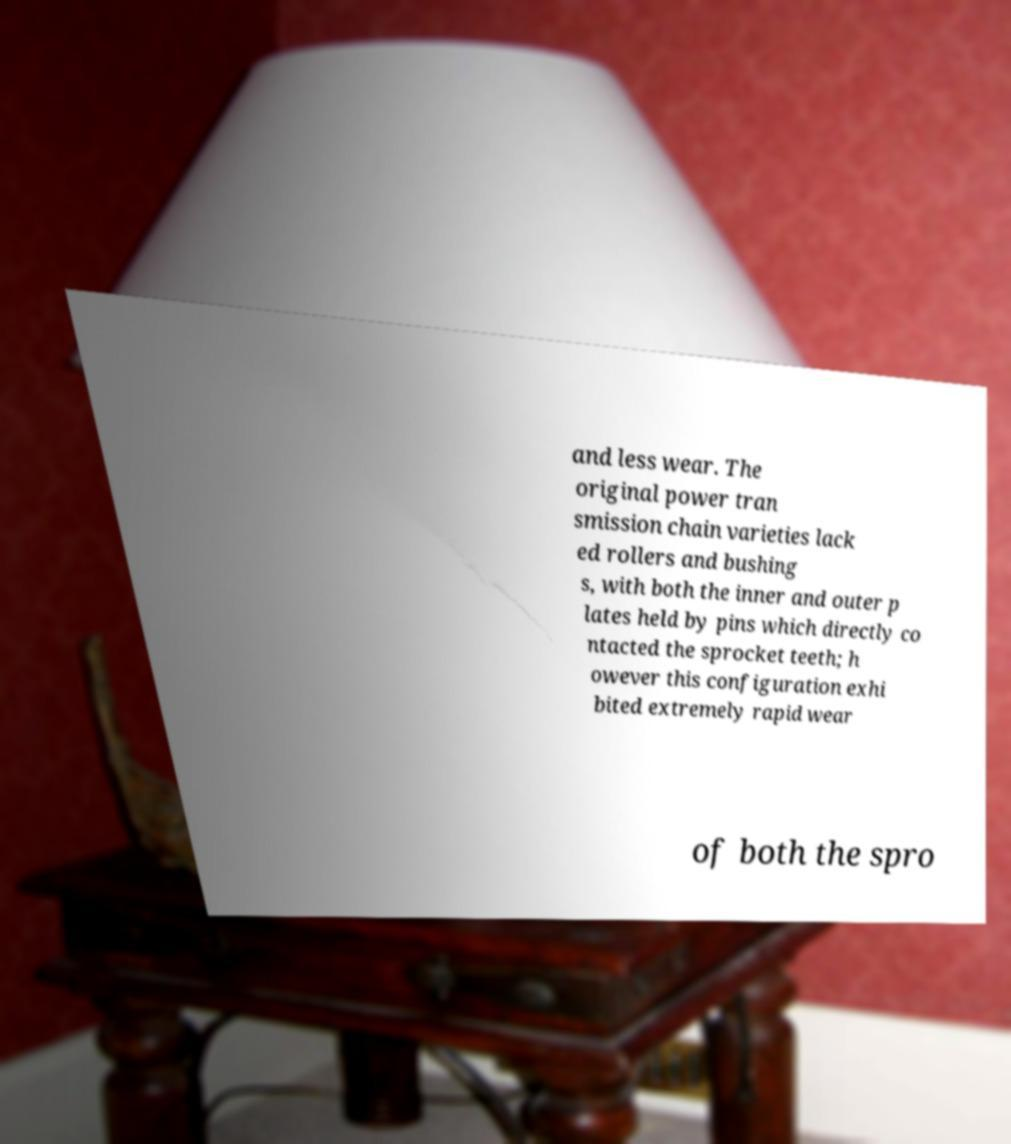Could you extract and type out the text from this image? and less wear. The original power tran smission chain varieties lack ed rollers and bushing s, with both the inner and outer p lates held by pins which directly co ntacted the sprocket teeth; h owever this configuration exhi bited extremely rapid wear of both the spro 